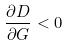Convert formula to latex. <formula><loc_0><loc_0><loc_500><loc_500>\frac { \partial D } { \partial G } < 0</formula> 